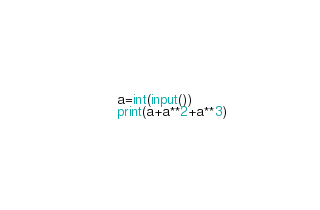<code> <loc_0><loc_0><loc_500><loc_500><_Python_>a=int(input())
print(a+a**2+a**3)</code> 